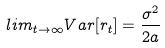Convert formula to latex. <formula><loc_0><loc_0><loc_500><loc_500>l i m _ { t \rightarrow \infty } V a r [ r _ { t } ] = \frac { \sigma ^ { 2 } } { 2 a }</formula> 